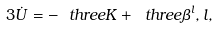Convert formula to latex. <formula><loc_0><loc_0><loc_500><loc_500>3 \dot { U } = - \ t h r e e K + \ t h r e e \beta ^ { l } { , l } ,</formula> 